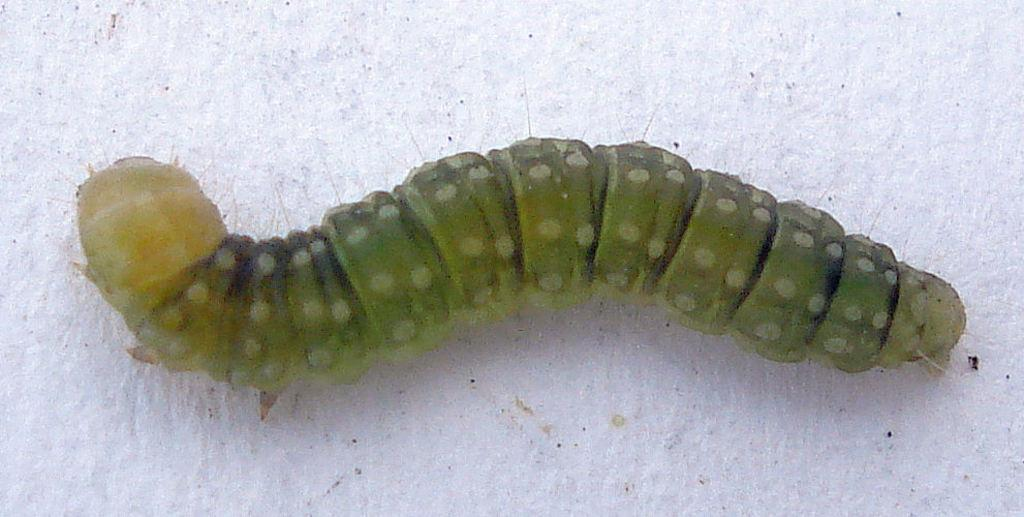What is the main subject of the image? There is a caterpillar in the image. Where is the caterpillar located in the image? The caterpillar is on a surface in the center of the image. What type of soap is the caterpillar using to clean itself in the image? There is no soap or indication of cleaning in the image; it simply shows a caterpillar on a surface. How many ants are visible in the image? There are no ants present in the image. 